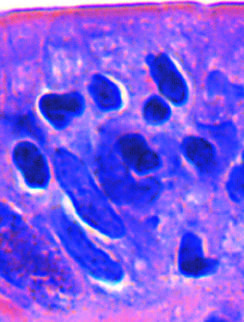whose densely stained nuclei (labeled t) are shown?
Answer the question using a single word or phrase. T lymphocytes 